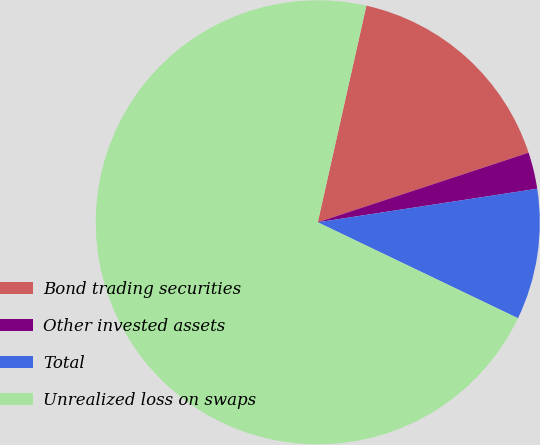Convert chart. <chart><loc_0><loc_0><loc_500><loc_500><pie_chart><fcel>Bond trading securities<fcel>Other invested assets<fcel>Total<fcel>Unrealized loss on swaps<nl><fcel>16.41%<fcel>2.66%<fcel>9.53%<fcel>71.4%<nl></chart> 